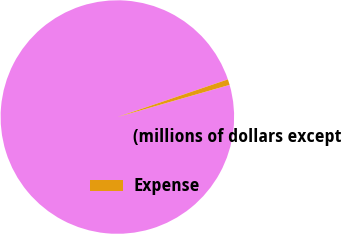Convert chart to OTSL. <chart><loc_0><loc_0><loc_500><loc_500><pie_chart><fcel>(millions of dollars except<fcel>Expense<nl><fcel>99.22%<fcel>0.78%<nl></chart> 